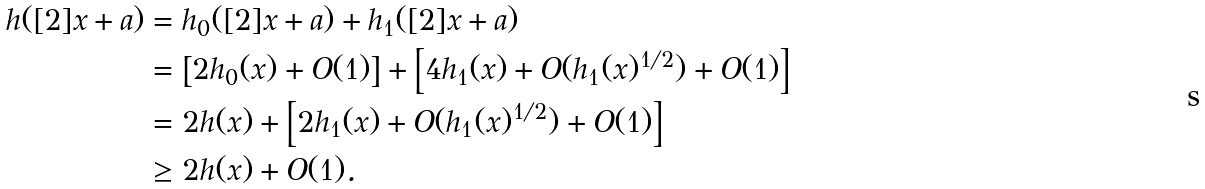Convert formula to latex. <formula><loc_0><loc_0><loc_500><loc_500>h ( [ 2 ] x + a ) & = h _ { 0 } ( [ 2 ] x + a ) + h _ { 1 } ( [ 2 ] x + a ) \\ & = \left [ 2 h _ { 0 } ( x ) + O ( 1 ) \right ] + \left [ 4 h _ { 1 } ( x ) + O ( h _ { 1 } ( x ) ^ { 1 / 2 } ) + O ( 1 ) \right ] \\ & = 2 h ( x ) + \left [ 2 h _ { 1 } ( x ) + O ( h _ { 1 } ( x ) ^ { 1 / 2 } ) + O ( 1 ) \right ] \\ & \geq 2 h ( x ) + O ( 1 ) .</formula> 